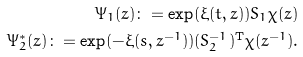Convert formula to latex. <formula><loc_0><loc_0><loc_500><loc_500>\Psi _ { 1 } ( z ) \colon = \exp ( \xi ( t , z ) ) S _ { 1 } \chi ( z ) \\ \Psi _ { 2 } ^ { * } ( z ) \colon = \exp ( - \xi ( s , z ^ { - 1 } ) ) ( S _ { 2 } ^ { - 1 } ) ^ { \mathrm T } \chi ( z ^ { - 1 } ) .</formula> 